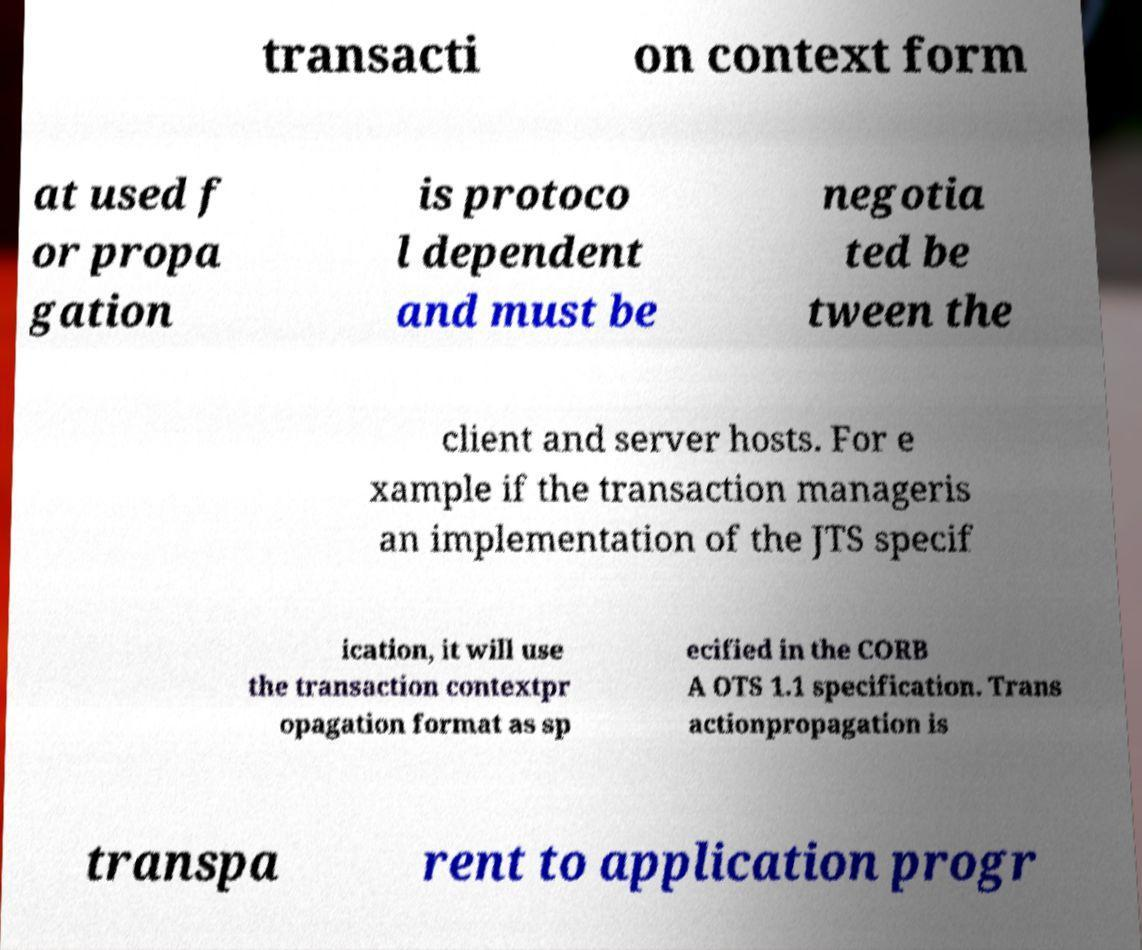What messages or text are displayed in this image? I need them in a readable, typed format. transacti on context form at used f or propa gation is protoco l dependent and must be negotia ted be tween the client and server hosts. For e xample if the transaction manageris an implementation of the JTS specif ication, it will use the transaction contextpr opagation format as sp ecified in the CORB A OTS 1.1 specification. Trans actionpropagation is transpa rent to application progr 